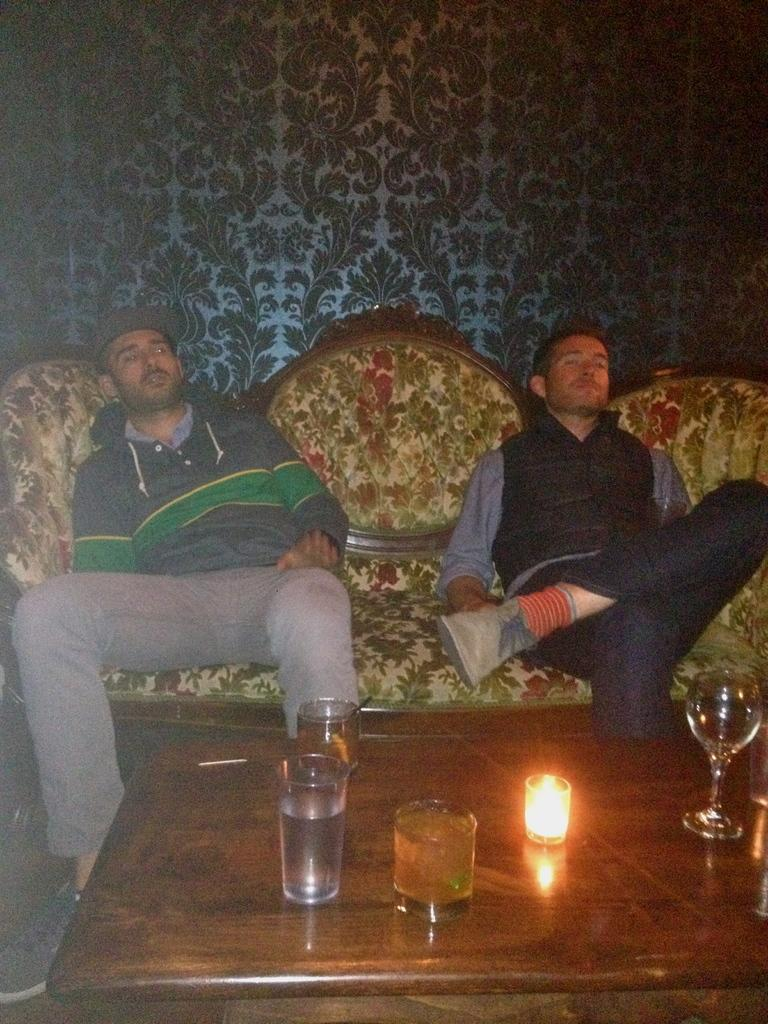How many people are in the image? There are two men in the image. What are the men doing in the image? The men are sitting on a couch. What is in front of the men? There is a table in front of the men. What objects can be seen on the table? There are glasses and a candle on the table. What type of spark can be seen coming from the candle in the image? There is no spark coming from the candle in the image. The candle is simply present on the table. 